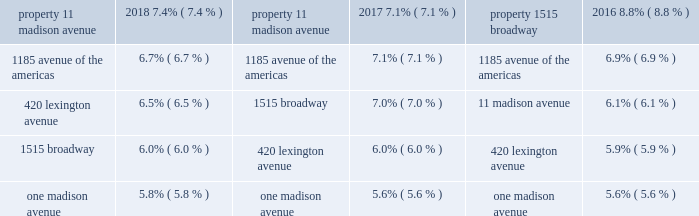Table of contents sl green realty corp .
And sl green operating partnership , l.p .
Notes to consolidated financial statements ( cont. ) december 31 , 2018 pricing models , replacement cost , and termination cost are used to determine fair value .
All methods of assessing fair value result in a general approximation of value , and such value may never actually be realized .
In the normal course of business , we are exposed to the effect of interest rate changes and limit these risks by following established risk management policies and procedures including the use of derivatives .
To address exposure to interest rates , derivatives are used primarily to fix the rate on debt based on floating-rate indices and manage the cost of borrowing obligations .
We use a variety of conventional derivative products .
These derivatives typically include interest rate swaps , caps , collars and floors .
We expressly prohibit the use of unconventional derivative instruments and using derivative instruments for trading or speculative purposes .
Further , we have a policy of only entering into contracts with major financial institutions based upon their credit ratings and other factors .
We may employ swaps , forwards or purchased options to hedge qualifying forecasted transactions .
Gains and losses related to these transactions are deferred and recognized in net income as interest expense in the same period or periods that the underlying transaction occurs , expires or is otherwise terminated .
Hedges that are reported at fair value and presented on the balance sheet could be characterized as cash flow hedges or fair value hedges .
Interest rate caps and collars are examples of cash flow hedges .
Cash flow hedges address the risk associated with future cash flows of interest payments .
For all hedges held by us and which were deemed to be fully effective in meeting the hedging objectives established by our corporate policy governing interest rate risk management , no net gains or losses were reported in earnings .
The changes in fair value of hedge instruments are reflected in accumulated other comprehensive income .
For derivative instruments not designated as hedging instruments , the gain or loss , resulting from the change in the estimated fair value of the derivative instruments , is recognized in current earnings during the period of change .
Earnings per share of the company the company presents both basic and diluted earnings per share , or eps , using the two-class method , which is an earnings allocation formula that determines eps for common stock and any participating securities according to dividends declared ( whether paid or unpaid ) .
Under the two-class method , basic eps is computed by dividing the income available to common stockholders by the weighted-average number of common stock shares outstanding for the period .
Basic eps includes participating securities , consisting of unvested restricted stock that receive nonforfeitable dividends similar to shares of common stock .
Diluted eps reflects the potential dilution that could occur if securities or other contracts to issue common stock were exercised or converted into common stock , where such exercise or conversion would result in a lower eps amount .
Diluted eps also includes units of limited partnership interest .
The dilutive effect of stock options is reflected in the weighted average diluted outstanding shares calculation by application of the treasury stock method .
There was no dilutive effect for the exchangeable senior notes as the conversion premium was to be paid in cash .
Earnings per unit of the operating partnership the operating partnership presents both basic and diluted earnings per unit , or epu , using the two-class method , which is an earnings allocation formula that determines epu for common units and any participating securities according to dividends declared ( whether paid or unpaid ) .
Under the two-class method , basic epu is computed by dividing the income available to common unitholders by the weighted-average number of common units outstanding for the period .
Basic epu includes participating securities , consisting of unvested restricted units that receive nonforfeitable dividends similar to shares of common units .
Diluted epu reflects the potential dilution that could occur if securities or other contracts to issue common units were exercised or converted into common units , where such exercise or conversion would result in a lower epu amount .
The dilutive effect of unit options is reflected in the weighted average diluted outstanding units calculation by application of the treasury stock method .
There was no dilutive effect for the exchangeable senior notes as the conversion premium was to be paid in cash .
Use of estimates the preparation of financial statements in conformity with accounting principles generally accepted in the united states requires management to make estimates and assumptions that affect the amounts reported in the financial statements and accompanying notes .
Actual results could differ from those estimates .
Concentrations of credit risk financial instruments that potentially subject us to concentrations of credit risk consist primarily of cash investments , debt and preferred equity investments and accounts receivable .
We place our cash investments with high quality financial institutions .
The collateral securing our debt and preferred equity investments is located in the new york metropolitan area .
See note 5 , "debt and preferred equity investments." table of contents sl green realty corp .
And sl green operating partnership , l.p .
Notes to consolidated financial statements ( cont. ) december 31 , 2018 we perform ongoing credit evaluations of our tenants and require most tenants to provide security deposits or letters of credit .
Though these security deposits and letters of credit are insufficient to meet the total value of a tenant's lease obligation , they are a measure of good faith and a source of funds to offset the economic costs associated with lost revenue and the costs associated with re-tenanting a space .
The properties in our real estate portfolio are located in the new york metropolitan area .
The tenants located in our buildings operate in various industries .
Other than one tenant , credit suisse securities ( usa ) , inc. , who accounts for 8.2% ( 8.2 % ) of our share of annualized cash rent , no other tenant in our portfolio accounted for more than 5.0% ( 5.0 % ) of our share of annualized cash rent , including our share of joint venture annualized cash rent , at december 31 , 2018 .
For the years ended december 31 , 2018 , 2017 , and 2016 , the following properties contributed more than 5.0% ( 5.0 % ) of our annualized cash rent , including our share of joint venture annualized cash rent: .
As of december 31 , 2018 , 68.7% ( 68.7 % ) of our work force is covered by six collective bargaining agreements and 56.0% ( 56.0 % ) of our work force , which services substantially all of our properties , is covered by collective bargaining agreements that expire in december 2019 .
See note 19 , "benefits plans." reclassification certain prior year balances have been reclassified to conform to our current year presentation .
Accounting standards updates in october 2018 , the fasb issued accounting standard update ( asu ) no .
2018-17 , consolidation ( topic 810 ) , targeted improvements to related party guidance for variable interest entities .
Under this amendment reporting entities , when determining if the decision-making fees are variable interests , are to consider indirect interests held through related parties under common control on a proportional basis rather than as a direct interest in its entirety .
The guidance is effective for the company for fiscal years beginning after december 15 , 2019 .
Early adoption is permitted .
The company has adopted this guidance and it had no impact on the company 2019s consolidated financial statements .
In august 2018 , the securities and exchange commission adopted a final rule that eliminated or amended disclosure requirements that were redundant or outdated in light of changes in its requirements , generally accepted accounting principles , or changes in the business environment .
The commission also referred certain disclosure requirements to the financial accounting standards board for potential incorporation into generally accepted accounting principles .
The rule is effective for filings after november 5 , 2018 .
The company assessed the impact of this rule and determined that the changes resulted in clarification or expansion of existing requirements .
The company early adopted the rule upon publication to the federal register on october 5 , 2018 and it did not have a material impact on the company 2019s consolidated financial statements .
In august 2018 , the fasb issued accounting standard update ( asu ) no .
2018-15 , intangibles - goodwill and other- internal-use software ( topic 350-40 ) , customer 2019s accounting for implementation costs incurred in a cloud computing arrangement that is a service contract .
The amendments provide guidance on accounting for fees paid when the arrangement includes a software license and align the requirements for capitalizing implementation costs incurred in a hosting arrangement that is a service contract with the requirements for capitalizing costs to develop or obtain internal-use software .
The guidance is effective for the company for fiscal years beginning after december 15 , 2019 .
Early adoption is permitted .
The company has not yet adopted this new guidance and does not expect it to have a material impact on the company 2019s consolidated financial statements when the new standard is implemented .
In august 2018 , the fasb issued asu no .
2018-13 , fair value measurement ( topic 820 ) , disclosure framework - changes to the disclosure requirements for fair value measurement .
This amendment removed , modified and added the disclosure requirements under topic 820 .
The changes are effective for the company for fiscal years beginning after december 15 , 2019 .
Early adoption is permitted for the removed or modified disclosures with adoption of the additional disclosures upon the effective date .
The company has not yet adopted this new guidance and does not expect it to have a material impact on the company 2019s consolidated financial statements when the new standard is implemented. .
Did credit suisse securities ( usa ) account for a greater % (  % ) of our share of annualized cash rent than the largest other property in 2018? 
Computations: (8.2 > 7.4)
Answer: yes. 